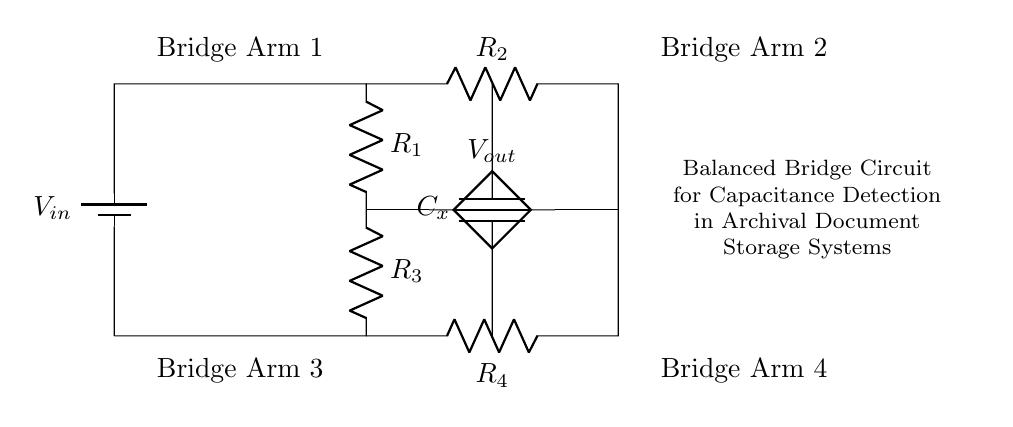What is the input voltage in this circuit? The input voltage, labeled as V_in, is shown connected to the circuit; typically, it would be a specific reference value provided by the power source but is not quantified in the diagram.
Answer: V_in What are the resistances in the circuit? The resistances listed in the circuit diagram are R_1, R_2, R_3, and R_4, which are designated with letters and connected in a specific structure.
Answer: R_1, R_2, R_3, R_4 What is the role of C_x in the circuit? C_x is a capacitor connected in the circuit that plays a vital role in measuring changes in capacitance, specifically important for detecting small changes as per the function of the balanced bridge configuration.
Answer: Detecting capacitance How many bridge arms are in this circuit? The circuit consists of four bridge arms: Bridge Arm 1, Bridge Arm 2, Bridge Arm 3, and Bridge Arm 4, which are indicated in the diagram labels and used for the balance condition of the bridge.
Answer: Four What happens if there is a small change in capacitance? A small change in the capacitance of C_x would cause an imbalance in the bridge which could result in a measurable change in the output voltage V_out. Balancing of the bridge is impacted, affecting the measurement outcome.
Answer: Change in V_out What does the bridge condition require for balance? The bridge condition for balance requires the ratio of the resistances in the two arms of the bridge to be equal; mathematically, it implies R_1/R_2 = R_3/R_4. This equality is crucial for the detection of small capacitance changes to function accurately.
Answer: R_1/R_2 = R_3/R_4 What is the significance of the output voltage V_out? V_out indicates the voltage difference resulting from imbalance in the bridge circuit and is a crucial measure when assessing changes in capacitance, essential for archival systems analyzing document conditions.
Answer: Measure of imbalance 